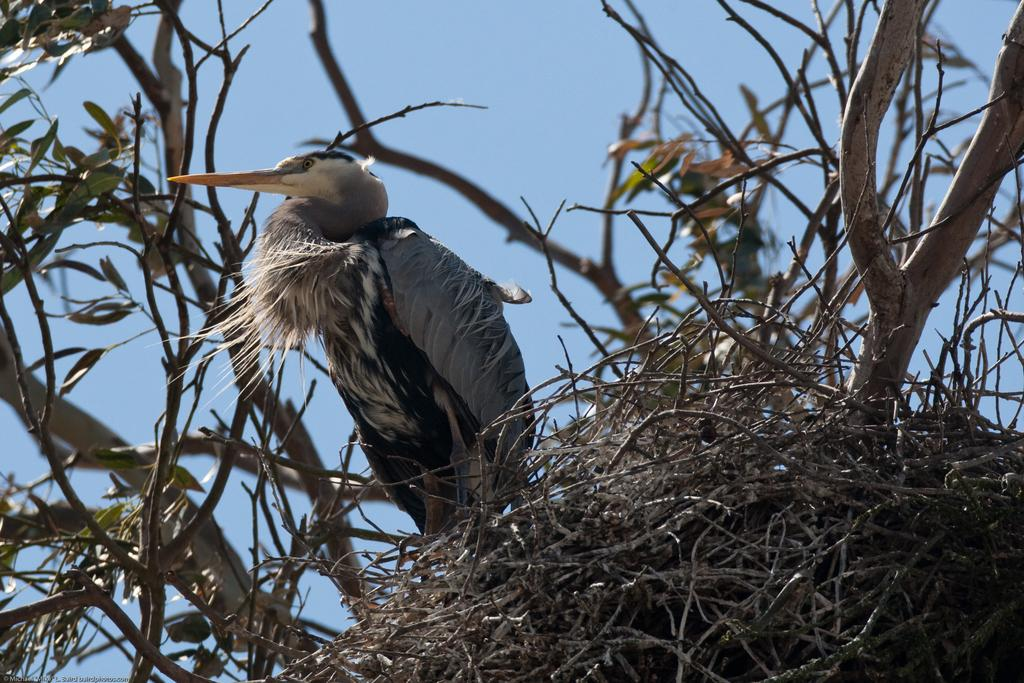What type of animal can be seen in the image? There is a bird in the image. Where is the bird located? The bird is on a tree in the image. What colors can be observed on the bird? The bird has ash, white, and black colors. What is present in the image besides the bird? There is a nest and leaves in the image. What is the color of the sky in the image? The sky is blue in the image. How many spiders are crawling on the bird in the image? There are no spiders present in the image; it features a bird on a tree. How long does it take for the bird to point at the nest in the image? The bird is not pointing at the nest, and there is no indication of time in the image. 